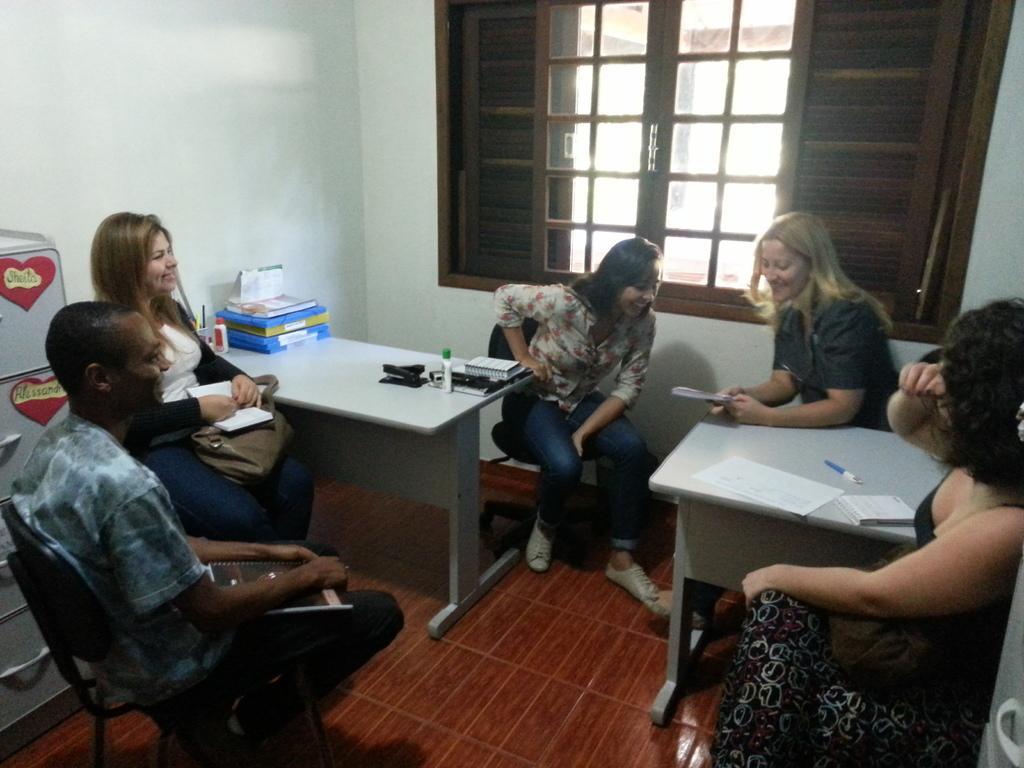Could you give a brief overview of what you see in this image? In this image there are group of people sitting in chairs , and on table there are books,bottles, pens,papers, and in background there is cupboard, window, wall. 